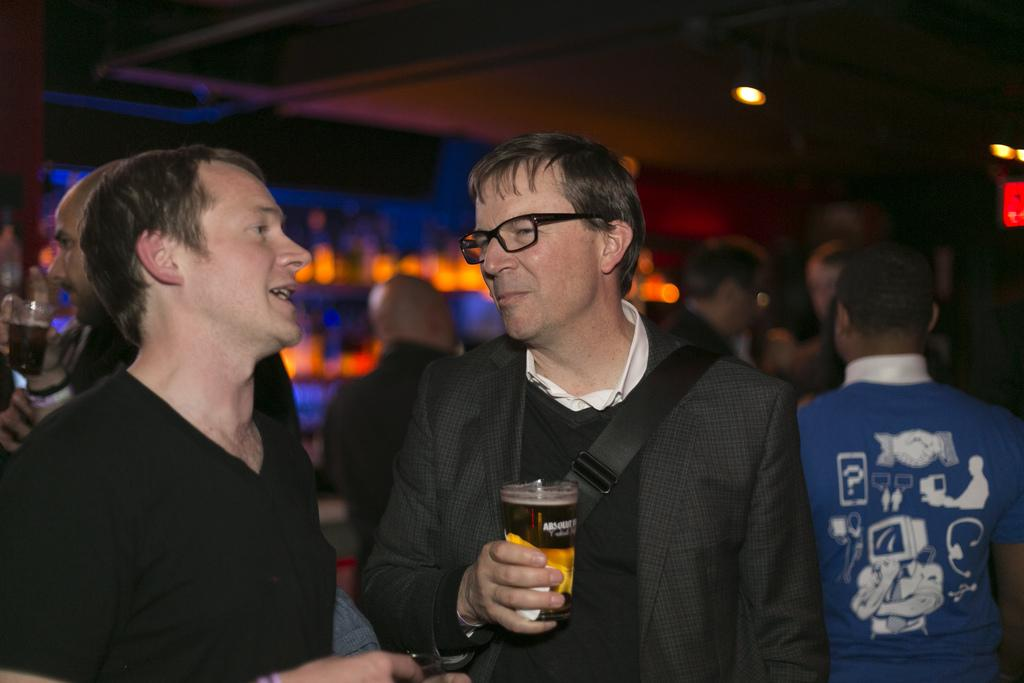What is happening in the image? There are people standing in the image. Can you describe the positioning of the people? One person is standing in the middle of the group. What can be observed about the person in the middle? The person in the middle is wearing spectacles. What is the person in the middle holding? The person in the middle is holding a glass in his hand. What type of fruit is being argued over by the people in the image? There is no fruit or argument present in the image; it simply shows people standing. What is the tendency of the people in the image to engage in a particular behavior? The image does not provide information about the people's tendencies or behaviors. 